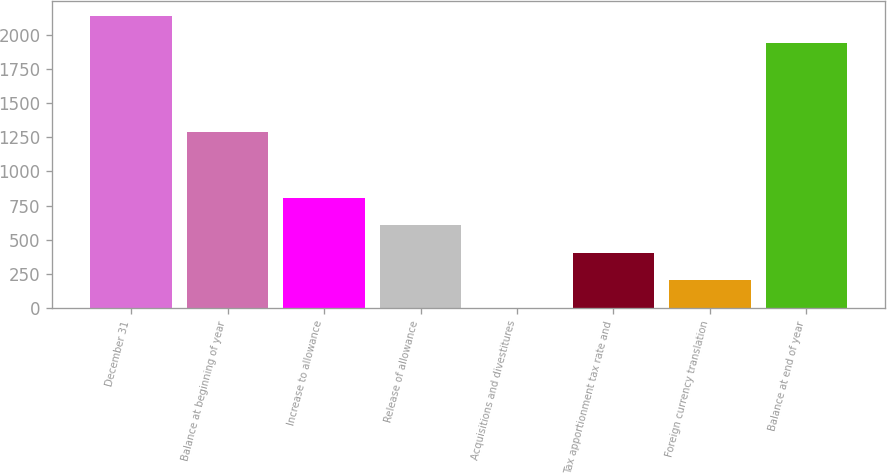Convert chart to OTSL. <chart><loc_0><loc_0><loc_500><loc_500><bar_chart><fcel>December 31<fcel>Balance at beginning of year<fcel>Increase to allowance<fcel>Release of allowance<fcel>Acquisitions and divestitures<fcel>Tax apportionment tax rate and<fcel>Foreign currency translation<fcel>Balance at end of year<nl><fcel>2141.5<fcel>1291<fcel>807<fcel>605.5<fcel>1<fcel>404<fcel>202.5<fcel>1940<nl></chart> 